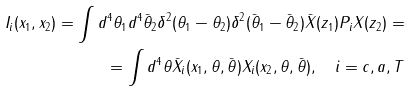Convert formula to latex. <formula><loc_0><loc_0><loc_500><loc_500>I _ { i } ( x _ { 1 } , x _ { 2 } ) = \int d ^ { 4 } \theta _ { 1 } d ^ { 4 } \bar { \theta } _ { 2 } \delta ^ { 2 } ( \theta _ { 1 } - \theta _ { 2 } ) \delta ^ { 2 } ( \bar { \theta } _ { 1 } - \bar { \theta } _ { 2 } ) \bar { X } ( z _ { 1 } ) P _ { i } X ( z _ { 2 } ) = \\ = \int d ^ { 4 } \theta \bar { X } _ { i } ( x _ { 1 } , \theta , \bar { \theta } ) X _ { i } ( x _ { 2 } , \theta , \bar { \theta } ) , \quad i = c , a , T</formula> 